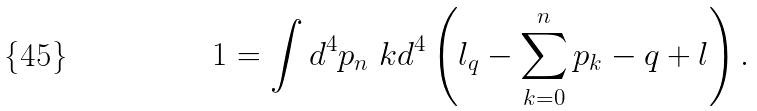<formula> <loc_0><loc_0><loc_500><loc_500>1 = \int d ^ { 4 } p _ { n } \ k d ^ { 4 } \left ( l _ { q } - \sum _ { k = 0 } ^ { n } p _ { k } - q + l \right ) .</formula> 